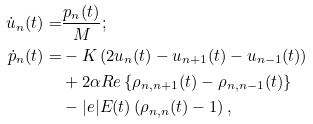Convert formula to latex. <formula><loc_0><loc_0><loc_500><loc_500>\dot { u } _ { n } ( t ) = & \frac { p _ { n } ( t ) } { M } ; \\ \dot { p } _ { n } ( t ) = & - K \left ( 2 u _ { n } ( t ) - u _ { n + 1 } ( t ) - u _ { n - 1 } ( t ) \right ) \\ & + 2 \alpha R e \left \{ \rho _ { n , n + 1 } ( t ) - \rho _ { n , n - 1 } ( t ) \right \} \\ & - | e | E ( t ) \left ( \rho _ { n , n } ( t ) - 1 \right ) ,</formula> 